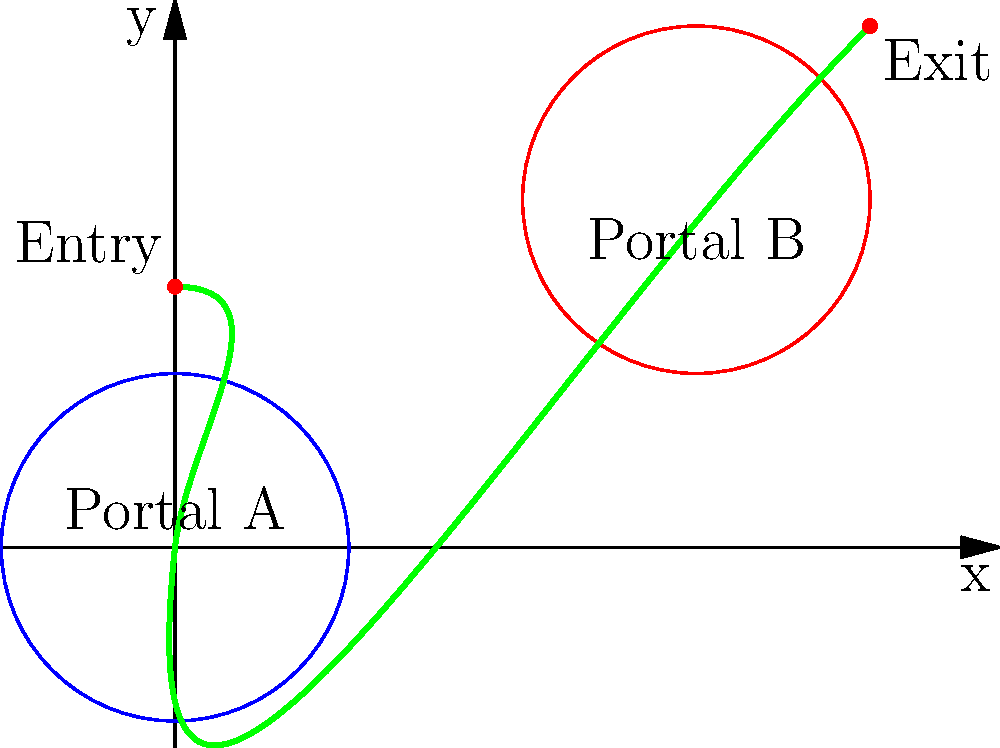In a game featuring portal teleportation, a custom coordinate system is designed where the position of an object is defined relative to the nearest portal. Given the diagram showing two portals (A and B) and a path of an object teleporting through them, calculate the change in the object's coordinates as it moves from the entry point to the exit point in this portal-relative coordinate system. Assume the portals have a radius of 2 units. To solve this problem, we need to follow these steps:

1. Identify the entry and exit points:
   Entry: $(0, 3)$
   Exit: $(8, 6)$

2. Determine the nearest portal for each point:
   Entry is closest to Portal A at $(0, 0)$
   Exit is closest to Portal B at $(6, 4)$

3. Calculate the coordinates relative to the nearest portal:
   For entry point: $(0-0, 3-0) = (0, 3)$
   For exit point: $(8-6, 6-4) = (2, 2)$

4. Convert to polar coordinates (r, θ) relative to the portal:
   Entry: $r = \sqrt{0^2 + 3^2} = 3$, $\theta = \arctan(3/0) = 90°$
   Exit: $r = \sqrt{2^2 + 2^2} = 2\sqrt{2}$, $\theta = \arctan(2/2) = 45°$

5. Calculate the change in coordinates:
   Δr = $2\sqrt{2} - 3$
   Δθ = $45° - 90° = -45°$

The change in coordinates is expressed as (Δr, Δθ) in the portal-relative polar coordinate system.
Answer: $(2\sqrt{2} - 3, -45°)$ 